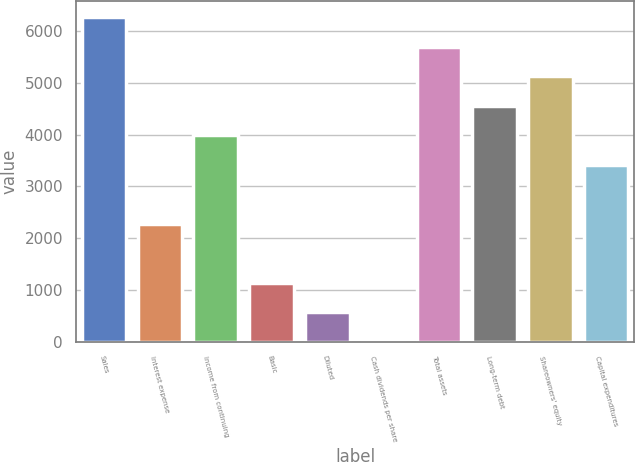<chart> <loc_0><loc_0><loc_500><loc_500><bar_chart><fcel>Sales<fcel>Interest expense<fcel>Income from continuing<fcel>Basic<fcel>Diluted<fcel>Cash dividends per share<fcel>Total assets<fcel>Long-term debt<fcel>Shareowners' equity<fcel>Capital expenditures<nl><fcel>6267.42<fcel>2279.8<fcel>3988.78<fcel>1140.48<fcel>570.82<fcel>1.16<fcel>5697.76<fcel>4558.44<fcel>5128.1<fcel>3419.12<nl></chart> 